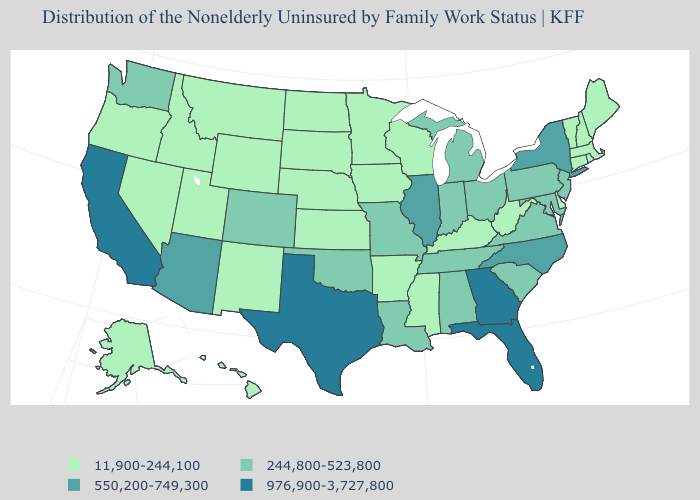Is the legend a continuous bar?
Keep it brief. No. Name the states that have a value in the range 244,800-523,800?
Keep it brief. Alabama, Colorado, Indiana, Louisiana, Maryland, Michigan, Missouri, New Jersey, Ohio, Oklahoma, Pennsylvania, South Carolina, Tennessee, Virginia, Washington. Does California have the highest value in the USA?
Write a very short answer. Yes. Does New Hampshire have the same value as Nevada?
Be succinct. Yes. Among the states that border Virginia , which have the highest value?
Short answer required. North Carolina. Name the states that have a value in the range 976,900-3,727,800?
Be succinct. California, Florida, Georgia, Texas. Which states have the lowest value in the USA?
Short answer required. Alaska, Arkansas, Connecticut, Delaware, Hawaii, Idaho, Iowa, Kansas, Kentucky, Maine, Massachusetts, Minnesota, Mississippi, Montana, Nebraska, Nevada, New Hampshire, New Mexico, North Dakota, Oregon, Rhode Island, South Dakota, Utah, Vermont, West Virginia, Wisconsin, Wyoming. Which states have the lowest value in the South?
Concise answer only. Arkansas, Delaware, Kentucky, Mississippi, West Virginia. Name the states that have a value in the range 550,200-749,300?
Short answer required. Arizona, Illinois, New York, North Carolina. Does Massachusetts have the lowest value in the Northeast?
Concise answer only. Yes. Does Alabama have the lowest value in the USA?
Give a very brief answer. No. Which states hav the highest value in the MidWest?
Write a very short answer. Illinois. Name the states that have a value in the range 11,900-244,100?
Concise answer only. Alaska, Arkansas, Connecticut, Delaware, Hawaii, Idaho, Iowa, Kansas, Kentucky, Maine, Massachusetts, Minnesota, Mississippi, Montana, Nebraska, Nevada, New Hampshire, New Mexico, North Dakota, Oregon, Rhode Island, South Dakota, Utah, Vermont, West Virginia, Wisconsin, Wyoming. Name the states that have a value in the range 976,900-3,727,800?
Quick response, please. California, Florida, Georgia, Texas. Does the map have missing data?
Answer briefly. No. 